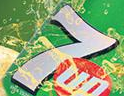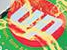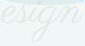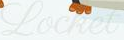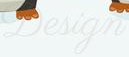What text appears in these images from left to right, separated by a semicolon? 7; up; esign; Locket; Design 